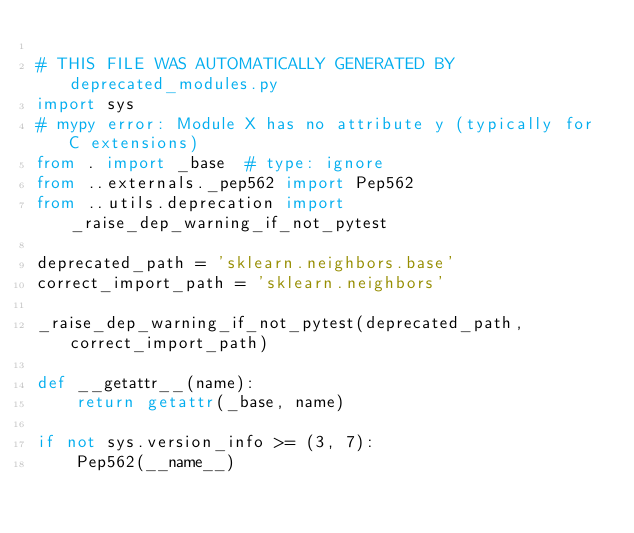Convert code to text. <code><loc_0><loc_0><loc_500><loc_500><_Python_>
# THIS FILE WAS AUTOMATICALLY GENERATED BY deprecated_modules.py
import sys
# mypy error: Module X has no attribute y (typically for C extensions)
from . import _base  # type: ignore
from ..externals._pep562 import Pep562
from ..utils.deprecation import _raise_dep_warning_if_not_pytest

deprecated_path = 'sklearn.neighbors.base'
correct_import_path = 'sklearn.neighbors'

_raise_dep_warning_if_not_pytest(deprecated_path, correct_import_path)

def __getattr__(name):
    return getattr(_base, name)

if not sys.version_info >= (3, 7):
    Pep562(__name__)
</code> 